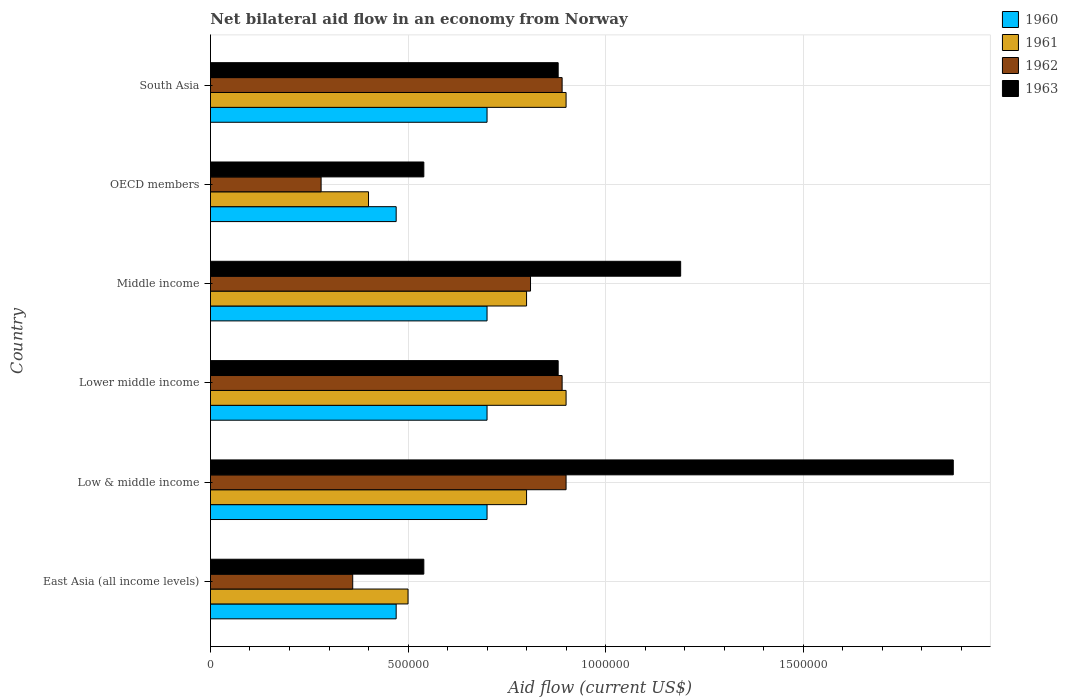How many different coloured bars are there?
Offer a terse response. 4. How many bars are there on the 4th tick from the top?
Your answer should be compact. 4. What is the label of the 5th group of bars from the top?
Your answer should be compact. Low & middle income. What is the net bilateral aid flow in 1960 in Low & middle income?
Your answer should be very brief. 7.00e+05. Across all countries, what is the maximum net bilateral aid flow in 1963?
Keep it short and to the point. 1.88e+06. In which country was the net bilateral aid flow in 1961 maximum?
Ensure brevity in your answer.  Lower middle income. In which country was the net bilateral aid flow in 1963 minimum?
Offer a very short reply. East Asia (all income levels). What is the total net bilateral aid flow in 1961 in the graph?
Your answer should be very brief. 4.30e+06. What is the difference between the net bilateral aid flow in 1961 in East Asia (all income levels) and that in OECD members?
Your response must be concise. 1.00e+05. What is the difference between the net bilateral aid flow in 1962 in OECD members and the net bilateral aid flow in 1963 in Lower middle income?
Your answer should be very brief. -6.00e+05. What is the average net bilateral aid flow in 1961 per country?
Keep it short and to the point. 7.17e+05. What is the difference between the net bilateral aid flow in 1960 and net bilateral aid flow in 1961 in Lower middle income?
Your response must be concise. -2.00e+05. What is the ratio of the net bilateral aid flow in 1960 in East Asia (all income levels) to that in Lower middle income?
Give a very brief answer. 0.67. Is the net bilateral aid flow in 1963 in Low & middle income less than that in South Asia?
Keep it short and to the point. No. Is the difference between the net bilateral aid flow in 1960 in Low & middle income and Middle income greater than the difference between the net bilateral aid flow in 1961 in Low & middle income and Middle income?
Your answer should be very brief. No. What is the difference between the highest and the second highest net bilateral aid flow in 1962?
Your response must be concise. 10000. In how many countries, is the net bilateral aid flow in 1963 greater than the average net bilateral aid flow in 1963 taken over all countries?
Your answer should be very brief. 2. Is the sum of the net bilateral aid flow in 1962 in Lower middle income and Middle income greater than the maximum net bilateral aid flow in 1960 across all countries?
Offer a terse response. Yes. Is it the case that in every country, the sum of the net bilateral aid flow in 1963 and net bilateral aid flow in 1962 is greater than the sum of net bilateral aid flow in 1960 and net bilateral aid flow in 1961?
Your response must be concise. No. Is it the case that in every country, the sum of the net bilateral aid flow in 1963 and net bilateral aid flow in 1961 is greater than the net bilateral aid flow in 1960?
Make the answer very short. Yes. How many countries are there in the graph?
Provide a short and direct response. 6. Are the values on the major ticks of X-axis written in scientific E-notation?
Give a very brief answer. No. Where does the legend appear in the graph?
Provide a succinct answer. Top right. How many legend labels are there?
Keep it short and to the point. 4. What is the title of the graph?
Keep it short and to the point. Net bilateral aid flow in an economy from Norway. Does "1985" appear as one of the legend labels in the graph?
Ensure brevity in your answer.  No. What is the Aid flow (current US$) of 1961 in East Asia (all income levels)?
Make the answer very short. 5.00e+05. What is the Aid flow (current US$) in 1963 in East Asia (all income levels)?
Make the answer very short. 5.40e+05. What is the Aid flow (current US$) in 1960 in Low & middle income?
Provide a short and direct response. 7.00e+05. What is the Aid flow (current US$) of 1961 in Low & middle income?
Offer a terse response. 8.00e+05. What is the Aid flow (current US$) of 1963 in Low & middle income?
Provide a succinct answer. 1.88e+06. What is the Aid flow (current US$) in 1960 in Lower middle income?
Keep it short and to the point. 7.00e+05. What is the Aid flow (current US$) in 1962 in Lower middle income?
Your answer should be compact. 8.90e+05. What is the Aid flow (current US$) in 1963 in Lower middle income?
Your response must be concise. 8.80e+05. What is the Aid flow (current US$) in 1960 in Middle income?
Your answer should be very brief. 7.00e+05. What is the Aid flow (current US$) in 1961 in Middle income?
Give a very brief answer. 8.00e+05. What is the Aid flow (current US$) in 1962 in Middle income?
Keep it short and to the point. 8.10e+05. What is the Aid flow (current US$) in 1963 in Middle income?
Ensure brevity in your answer.  1.19e+06. What is the Aid flow (current US$) in 1961 in OECD members?
Your response must be concise. 4.00e+05. What is the Aid flow (current US$) in 1962 in OECD members?
Keep it short and to the point. 2.80e+05. What is the Aid flow (current US$) in 1963 in OECD members?
Your answer should be compact. 5.40e+05. What is the Aid flow (current US$) in 1962 in South Asia?
Your response must be concise. 8.90e+05. What is the Aid flow (current US$) in 1963 in South Asia?
Give a very brief answer. 8.80e+05. Across all countries, what is the maximum Aid flow (current US$) of 1960?
Offer a very short reply. 7.00e+05. Across all countries, what is the maximum Aid flow (current US$) in 1961?
Your answer should be compact. 9.00e+05. Across all countries, what is the maximum Aid flow (current US$) in 1962?
Give a very brief answer. 9.00e+05. Across all countries, what is the maximum Aid flow (current US$) of 1963?
Make the answer very short. 1.88e+06. Across all countries, what is the minimum Aid flow (current US$) of 1960?
Make the answer very short. 4.70e+05. Across all countries, what is the minimum Aid flow (current US$) of 1963?
Offer a terse response. 5.40e+05. What is the total Aid flow (current US$) of 1960 in the graph?
Provide a short and direct response. 3.74e+06. What is the total Aid flow (current US$) in 1961 in the graph?
Provide a short and direct response. 4.30e+06. What is the total Aid flow (current US$) in 1962 in the graph?
Make the answer very short. 4.13e+06. What is the total Aid flow (current US$) in 1963 in the graph?
Your answer should be very brief. 5.91e+06. What is the difference between the Aid flow (current US$) of 1960 in East Asia (all income levels) and that in Low & middle income?
Your answer should be compact. -2.30e+05. What is the difference between the Aid flow (current US$) of 1961 in East Asia (all income levels) and that in Low & middle income?
Your answer should be very brief. -3.00e+05. What is the difference between the Aid flow (current US$) of 1962 in East Asia (all income levels) and that in Low & middle income?
Make the answer very short. -5.40e+05. What is the difference between the Aid flow (current US$) of 1963 in East Asia (all income levels) and that in Low & middle income?
Provide a short and direct response. -1.34e+06. What is the difference between the Aid flow (current US$) in 1960 in East Asia (all income levels) and that in Lower middle income?
Provide a short and direct response. -2.30e+05. What is the difference between the Aid flow (current US$) of 1961 in East Asia (all income levels) and that in Lower middle income?
Your answer should be very brief. -4.00e+05. What is the difference between the Aid flow (current US$) in 1962 in East Asia (all income levels) and that in Lower middle income?
Your answer should be very brief. -5.30e+05. What is the difference between the Aid flow (current US$) in 1963 in East Asia (all income levels) and that in Lower middle income?
Your answer should be compact. -3.40e+05. What is the difference between the Aid flow (current US$) in 1962 in East Asia (all income levels) and that in Middle income?
Your answer should be compact. -4.50e+05. What is the difference between the Aid flow (current US$) in 1963 in East Asia (all income levels) and that in Middle income?
Keep it short and to the point. -6.50e+05. What is the difference between the Aid flow (current US$) of 1962 in East Asia (all income levels) and that in OECD members?
Your answer should be compact. 8.00e+04. What is the difference between the Aid flow (current US$) in 1960 in East Asia (all income levels) and that in South Asia?
Keep it short and to the point. -2.30e+05. What is the difference between the Aid flow (current US$) of 1961 in East Asia (all income levels) and that in South Asia?
Make the answer very short. -4.00e+05. What is the difference between the Aid flow (current US$) of 1962 in East Asia (all income levels) and that in South Asia?
Your response must be concise. -5.30e+05. What is the difference between the Aid flow (current US$) of 1960 in Low & middle income and that in Lower middle income?
Keep it short and to the point. 0. What is the difference between the Aid flow (current US$) in 1962 in Low & middle income and that in Lower middle income?
Ensure brevity in your answer.  10000. What is the difference between the Aid flow (current US$) in 1962 in Low & middle income and that in Middle income?
Your answer should be compact. 9.00e+04. What is the difference between the Aid flow (current US$) of 1963 in Low & middle income and that in Middle income?
Ensure brevity in your answer.  6.90e+05. What is the difference between the Aid flow (current US$) in 1962 in Low & middle income and that in OECD members?
Your answer should be compact. 6.20e+05. What is the difference between the Aid flow (current US$) of 1963 in Low & middle income and that in OECD members?
Ensure brevity in your answer.  1.34e+06. What is the difference between the Aid flow (current US$) in 1960 in Low & middle income and that in South Asia?
Offer a very short reply. 0. What is the difference between the Aid flow (current US$) of 1961 in Low & middle income and that in South Asia?
Your answer should be compact. -1.00e+05. What is the difference between the Aid flow (current US$) of 1962 in Low & middle income and that in South Asia?
Provide a succinct answer. 10000. What is the difference between the Aid flow (current US$) of 1960 in Lower middle income and that in Middle income?
Provide a succinct answer. 0. What is the difference between the Aid flow (current US$) of 1963 in Lower middle income and that in Middle income?
Your response must be concise. -3.10e+05. What is the difference between the Aid flow (current US$) in 1960 in Lower middle income and that in OECD members?
Provide a succinct answer. 2.30e+05. What is the difference between the Aid flow (current US$) of 1962 in Lower middle income and that in OECD members?
Keep it short and to the point. 6.10e+05. What is the difference between the Aid flow (current US$) in 1963 in Lower middle income and that in OECD members?
Give a very brief answer. 3.40e+05. What is the difference between the Aid flow (current US$) of 1960 in Lower middle income and that in South Asia?
Your answer should be very brief. 0. What is the difference between the Aid flow (current US$) of 1961 in Lower middle income and that in South Asia?
Your answer should be very brief. 0. What is the difference between the Aid flow (current US$) of 1962 in Lower middle income and that in South Asia?
Give a very brief answer. 0. What is the difference between the Aid flow (current US$) of 1963 in Lower middle income and that in South Asia?
Your response must be concise. 0. What is the difference between the Aid flow (current US$) in 1962 in Middle income and that in OECD members?
Your answer should be very brief. 5.30e+05. What is the difference between the Aid flow (current US$) of 1963 in Middle income and that in OECD members?
Your response must be concise. 6.50e+05. What is the difference between the Aid flow (current US$) of 1960 in Middle income and that in South Asia?
Your response must be concise. 0. What is the difference between the Aid flow (current US$) in 1961 in Middle income and that in South Asia?
Ensure brevity in your answer.  -1.00e+05. What is the difference between the Aid flow (current US$) of 1962 in Middle income and that in South Asia?
Offer a very short reply. -8.00e+04. What is the difference between the Aid flow (current US$) of 1963 in Middle income and that in South Asia?
Make the answer very short. 3.10e+05. What is the difference between the Aid flow (current US$) of 1960 in OECD members and that in South Asia?
Keep it short and to the point. -2.30e+05. What is the difference between the Aid flow (current US$) in 1961 in OECD members and that in South Asia?
Keep it short and to the point. -5.00e+05. What is the difference between the Aid flow (current US$) of 1962 in OECD members and that in South Asia?
Keep it short and to the point. -6.10e+05. What is the difference between the Aid flow (current US$) in 1960 in East Asia (all income levels) and the Aid flow (current US$) in 1961 in Low & middle income?
Your answer should be compact. -3.30e+05. What is the difference between the Aid flow (current US$) in 1960 in East Asia (all income levels) and the Aid flow (current US$) in 1962 in Low & middle income?
Provide a short and direct response. -4.30e+05. What is the difference between the Aid flow (current US$) in 1960 in East Asia (all income levels) and the Aid flow (current US$) in 1963 in Low & middle income?
Offer a very short reply. -1.41e+06. What is the difference between the Aid flow (current US$) in 1961 in East Asia (all income levels) and the Aid flow (current US$) in 1962 in Low & middle income?
Ensure brevity in your answer.  -4.00e+05. What is the difference between the Aid flow (current US$) in 1961 in East Asia (all income levels) and the Aid flow (current US$) in 1963 in Low & middle income?
Ensure brevity in your answer.  -1.38e+06. What is the difference between the Aid flow (current US$) in 1962 in East Asia (all income levels) and the Aid flow (current US$) in 1963 in Low & middle income?
Offer a terse response. -1.52e+06. What is the difference between the Aid flow (current US$) in 1960 in East Asia (all income levels) and the Aid flow (current US$) in 1961 in Lower middle income?
Your response must be concise. -4.30e+05. What is the difference between the Aid flow (current US$) in 1960 in East Asia (all income levels) and the Aid flow (current US$) in 1962 in Lower middle income?
Provide a short and direct response. -4.20e+05. What is the difference between the Aid flow (current US$) in 1960 in East Asia (all income levels) and the Aid flow (current US$) in 1963 in Lower middle income?
Ensure brevity in your answer.  -4.10e+05. What is the difference between the Aid flow (current US$) of 1961 in East Asia (all income levels) and the Aid flow (current US$) of 1962 in Lower middle income?
Your response must be concise. -3.90e+05. What is the difference between the Aid flow (current US$) in 1961 in East Asia (all income levels) and the Aid flow (current US$) in 1963 in Lower middle income?
Ensure brevity in your answer.  -3.80e+05. What is the difference between the Aid flow (current US$) of 1962 in East Asia (all income levels) and the Aid flow (current US$) of 1963 in Lower middle income?
Provide a short and direct response. -5.20e+05. What is the difference between the Aid flow (current US$) of 1960 in East Asia (all income levels) and the Aid flow (current US$) of 1961 in Middle income?
Keep it short and to the point. -3.30e+05. What is the difference between the Aid flow (current US$) in 1960 in East Asia (all income levels) and the Aid flow (current US$) in 1962 in Middle income?
Ensure brevity in your answer.  -3.40e+05. What is the difference between the Aid flow (current US$) of 1960 in East Asia (all income levels) and the Aid flow (current US$) of 1963 in Middle income?
Provide a succinct answer. -7.20e+05. What is the difference between the Aid flow (current US$) in 1961 in East Asia (all income levels) and the Aid flow (current US$) in 1962 in Middle income?
Provide a short and direct response. -3.10e+05. What is the difference between the Aid flow (current US$) in 1961 in East Asia (all income levels) and the Aid flow (current US$) in 1963 in Middle income?
Give a very brief answer. -6.90e+05. What is the difference between the Aid flow (current US$) in 1962 in East Asia (all income levels) and the Aid flow (current US$) in 1963 in Middle income?
Give a very brief answer. -8.30e+05. What is the difference between the Aid flow (current US$) in 1960 in East Asia (all income levels) and the Aid flow (current US$) in 1962 in OECD members?
Your answer should be compact. 1.90e+05. What is the difference between the Aid flow (current US$) of 1961 in East Asia (all income levels) and the Aid flow (current US$) of 1962 in OECD members?
Your answer should be compact. 2.20e+05. What is the difference between the Aid flow (current US$) of 1961 in East Asia (all income levels) and the Aid flow (current US$) of 1963 in OECD members?
Keep it short and to the point. -4.00e+04. What is the difference between the Aid flow (current US$) in 1960 in East Asia (all income levels) and the Aid flow (current US$) in 1961 in South Asia?
Provide a succinct answer. -4.30e+05. What is the difference between the Aid flow (current US$) of 1960 in East Asia (all income levels) and the Aid flow (current US$) of 1962 in South Asia?
Give a very brief answer. -4.20e+05. What is the difference between the Aid flow (current US$) in 1960 in East Asia (all income levels) and the Aid flow (current US$) in 1963 in South Asia?
Your answer should be compact. -4.10e+05. What is the difference between the Aid flow (current US$) in 1961 in East Asia (all income levels) and the Aid flow (current US$) in 1962 in South Asia?
Provide a succinct answer. -3.90e+05. What is the difference between the Aid flow (current US$) of 1961 in East Asia (all income levels) and the Aid flow (current US$) of 1963 in South Asia?
Your response must be concise. -3.80e+05. What is the difference between the Aid flow (current US$) in 1962 in East Asia (all income levels) and the Aid flow (current US$) in 1963 in South Asia?
Provide a short and direct response. -5.20e+05. What is the difference between the Aid flow (current US$) of 1960 in Low & middle income and the Aid flow (current US$) of 1961 in Lower middle income?
Your answer should be compact. -2.00e+05. What is the difference between the Aid flow (current US$) in 1960 in Low & middle income and the Aid flow (current US$) in 1963 in Lower middle income?
Provide a short and direct response. -1.80e+05. What is the difference between the Aid flow (current US$) in 1961 in Low & middle income and the Aid flow (current US$) in 1962 in Lower middle income?
Provide a succinct answer. -9.00e+04. What is the difference between the Aid flow (current US$) in 1962 in Low & middle income and the Aid flow (current US$) in 1963 in Lower middle income?
Make the answer very short. 2.00e+04. What is the difference between the Aid flow (current US$) in 1960 in Low & middle income and the Aid flow (current US$) in 1963 in Middle income?
Your answer should be compact. -4.90e+05. What is the difference between the Aid flow (current US$) in 1961 in Low & middle income and the Aid flow (current US$) in 1963 in Middle income?
Ensure brevity in your answer.  -3.90e+05. What is the difference between the Aid flow (current US$) in 1962 in Low & middle income and the Aid flow (current US$) in 1963 in Middle income?
Offer a terse response. -2.90e+05. What is the difference between the Aid flow (current US$) in 1960 in Low & middle income and the Aid flow (current US$) in 1961 in OECD members?
Offer a terse response. 3.00e+05. What is the difference between the Aid flow (current US$) of 1961 in Low & middle income and the Aid flow (current US$) of 1962 in OECD members?
Keep it short and to the point. 5.20e+05. What is the difference between the Aid flow (current US$) in 1961 in Low & middle income and the Aid flow (current US$) in 1963 in OECD members?
Provide a succinct answer. 2.60e+05. What is the difference between the Aid flow (current US$) in 1960 in Low & middle income and the Aid flow (current US$) in 1961 in South Asia?
Your answer should be compact. -2.00e+05. What is the difference between the Aid flow (current US$) of 1960 in Low & middle income and the Aid flow (current US$) of 1962 in South Asia?
Provide a short and direct response. -1.90e+05. What is the difference between the Aid flow (current US$) in 1960 in Low & middle income and the Aid flow (current US$) in 1963 in South Asia?
Your answer should be very brief. -1.80e+05. What is the difference between the Aid flow (current US$) in 1961 in Low & middle income and the Aid flow (current US$) in 1963 in South Asia?
Ensure brevity in your answer.  -8.00e+04. What is the difference between the Aid flow (current US$) of 1960 in Lower middle income and the Aid flow (current US$) of 1962 in Middle income?
Your response must be concise. -1.10e+05. What is the difference between the Aid flow (current US$) in 1960 in Lower middle income and the Aid flow (current US$) in 1963 in Middle income?
Provide a short and direct response. -4.90e+05. What is the difference between the Aid flow (current US$) of 1961 in Lower middle income and the Aid flow (current US$) of 1963 in Middle income?
Your answer should be very brief. -2.90e+05. What is the difference between the Aid flow (current US$) of 1960 in Lower middle income and the Aid flow (current US$) of 1961 in OECD members?
Give a very brief answer. 3.00e+05. What is the difference between the Aid flow (current US$) in 1960 in Lower middle income and the Aid flow (current US$) in 1963 in OECD members?
Your answer should be very brief. 1.60e+05. What is the difference between the Aid flow (current US$) in 1961 in Lower middle income and the Aid flow (current US$) in 1962 in OECD members?
Provide a short and direct response. 6.20e+05. What is the difference between the Aid flow (current US$) in 1962 in Lower middle income and the Aid flow (current US$) in 1963 in OECD members?
Offer a very short reply. 3.50e+05. What is the difference between the Aid flow (current US$) in 1960 in Lower middle income and the Aid flow (current US$) in 1961 in South Asia?
Provide a succinct answer. -2.00e+05. What is the difference between the Aid flow (current US$) in 1960 in Lower middle income and the Aid flow (current US$) in 1963 in South Asia?
Provide a short and direct response. -1.80e+05. What is the difference between the Aid flow (current US$) of 1961 in Lower middle income and the Aid flow (current US$) of 1963 in South Asia?
Ensure brevity in your answer.  2.00e+04. What is the difference between the Aid flow (current US$) of 1962 in Lower middle income and the Aid flow (current US$) of 1963 in South Asia?
Your response must be concise. 10000. What is the difference between the Aid flow (current US$) of 1960 in Middle income and the Aid flow (current US$) of 1961 in OECD members?
Ensure brevity in your answer.  3.00e+05. What is the difference between the Aid flow (current US$) of 1960 in Middle income and the Aid flow (current US$) of 1963 in OECD members?
Ensure brevity in your answer.  1.60e+05. What is the difference between the Aid flow (current US$) of 1961 in Middle income and the Aid flow (current US$) of 1962 in OECD members?
Ensure brevity in your answer.  5.20e+05. What is the difference between the Aid flow (current US$) of 1962 in Middle income and the Aid flow (current US$) of 1963 in OECD members?
Make the answer very short. 2.70e+05. What is the difference between the Aid flow (current US$) in 1960 in Middle income and the Aid flow (current US$) in 1961 in South Asia?
Provide a succinct answer. -2.00e+05. What is the difference between the Aid flow (current US$) in 1960 in Middle income and the Aid flow (current US$) in 1962 in South Asia?
Your answer should be compact. -1.90e+05. What is the difference between the Aid flow (current US$) of 1961 in Middle income and the Aid flow (current US$) of 1962 in South Asia?
Offer a very short reply. -9.00e+04. What is the difference between the Aid flow (current US$) of 1960 in OECD members and the Aid flow (current US$) of 1961 in South Asia?
Keep it short and to the point. -4.30e+05. What is the difference between the Aid flow (current US$) in 1960 in OECD members and the Aid flow (current US$) in 1962 in South Asia?
Ensure brevity in your answer.  -4.20e+05. What is the difference between the Aid flow (current US$) of 1960 in OECD members and the Aid flow (current US$) of 1963 in South Asia?
Offer a terse response. -4.10e+05. What is the difference between the Aid flow (current US$) in 1961 in OECD members and the Aid flow (current US$) in 1962 in South Asia?
Offer a terse response. -4.90e+05. What is the difference between the Aid flow (current US$) of 1961 in OECD members and the Aid flow (current US$) of 1963 in South Asia?
Provide a short and direct response. -4.80e+05. What is the difference between the Aid flow (current US$) in 1962 in OECD members and the Aid flow (current US$) in 1963 in South Asia?
Provide a succinct answer. -6.00e+05. What is the average Aid flow (current US$) of 1960 per country?
Make the answer very short. 6.23e+05. What is the average Aid flow (current US$) of 1961 per country?
Give a very brief answer. 7.17e+05. What is the average Aid flow (current US$) in 1962 per country?
Give a very brief answer. 6.88e+05. What is the average Aid flow (current US$) of 1963 per country?
Your answer should be very brief. 9.85e+05. What is the difference between the Aid flow (current US$) in 1960 and Aid flow (current US$) in 1961 in East Asia (all income levels)?
Ensure brevity in your answer.  -3.00e+04. What is the difference between the Aid flow (current US$) in 1960 and Aid flow (current US$) in 1962 in East Asia (all income levels)?
Ensure brevity in your answer.  1.10e+05. What is the difference between the Aid flow (current US$) of 1960 and Aid flow (current US$) of 1963 in East Asia (all income levels)?
Ensure brevity in your answer.  -7.00e+04. What is the difference between the Aid flow (current US$) in 1961 and Aid flow (current US$) in 1962 in East Asia (all income levels)?
Offer a terse response. 1.40e+05. What is the difference between the Aid flow (current US$) of 1960 and Aid flow (current US$) of 1961 in Low & middle income?
Your response must be concise. -1.00e+05. What is the difference between the Aid flow (current US$) in 1960 and Aid flow (current US$) in 1963 in Low & middle income?
Provide a succinct answer. -1.18e+06. What is the difference between the Aid flow (current US$) in 1961 and Aid flow (current US$) in 1962 in Low & middle income?
Ensure brevity in your answer.  -1.00e+05. What is the difference between the Aid flow (current US$) of 1961 and Aid flow (current US$) of 1963 in Low & middle income?
Offer a terse response. -1.08e+06. What is the difference between the Aid flow (current US$) of 1962 and Aid flow (current US$) of 1963 in Low & middle income?
Keep it short and to the point. -9.80e+05. What is the difference between the Aid flow (current US$) of 1960 and Aid flow (current US$) of 1962 in Lower middle income?
Provide a succinct answer. -1.90e+05. What is the difference between the Aid flow (current US$) of 1960 and Aid flow (current US$) of 1963 in Lower middle income?
Give a very brief answer. -1.80e+05. What is the difference between the Aid flow (current US$) of 1961 and Aid flow (current US$) of 1963 in Lower middle income?
Give a very brief answer. 2.00e+04. What is the difference between the Aid flow (current US$) of 1962 and Aid flow (current US$) of 1963 in Lower middle income?
Provide a succinct answer. 10000. What is the difference between the Aid flow (current US$) in 1960 and Aid flow (current US$) in 1963 in Middle income?
Make the answer very short. -4.90e+05. What is the difference between the Aid flow (current US$) in 1961 and Aid flow (current US$) in 1962 in Middle income?
Give a very brief answer. -10000. What is the difference between the Aid flow (current US$) of 1961 and Aid flow (current US$) of 1963 in Middle income?
Keep it short and to the point. -3.90e+05. What is the difference between the Aid flow (current US$) of 1962 and Aid flow (current US$) of 1963 in Middle income?
Offer a terse response. -3.80e+05. What is the difference between the Aid flow (current US$) in 1960 and Aid flow (current US$) in 1961 in OECD members?
Your response must be concise. 7.00e+04. What is the difference between the Aid flow (current US$) in 1961 and Aid flow (current US$) in 1963 in OECD members?
Your answer should be very brief. -1.40e+05. What is the difference between the Aid flow (current US$) of 1962 and Aid flow (current US$) of 1963 in OECD members?
Provide a succinct answer. -2.60e+05. What is the difference between the Aid flow (current US$) of 1960 and Aid flow (current US$) of 1961 in South Asia?
Give a very brief answer. -2.00e+05. What is the difference between the Aid flow (current US$) in 1960 and Aid flow (current US$) in 1963 in South Asia?
Ensure brevity in your answer.  -1.80e+05. What is the difference between the Aid flow (current US$) in 1961 and Aid flow (current US$) in 1962 in South Asia?
Ensure brevity in your answer.  10000. What is the ratio of the Aid flow (current US$) in 1960 in East Asia (all income levels) to that in Low & middle income?
Provide a short and direct response. 0.67. What is the ratio of the Aid flow (current US$) in 1963 in East Asia (all income levels) to that in Low & middle income?
Offer a very short reply. 0.29. What is the ratio of the Aid flow (current US$) of 1960 in East Asia (all income levels) to that in Lower middle income?
Provide a succinct answer. 0.67. What is the ratio of the Aid flow (current US$) in 1961 in East Asia (all income levels) to that in Lower middle income?
Ensure brevity in your answer.  0.56. What is the ratio of the Aid flow (current US$) in 1962 in East Asia (all income levels) to that in Lower middle income?
Keep it short and to the point. 0.4. What is the ratio of the Aid flow (current US$) of 1963 in East Asia (all income levels) to that in Lower middle income?
Offer a terse response. 0.61. What is the ratio of the Aid flow (current US$) of 1960 in East Asia (all income levels) to that in Middle income?
Make the answer very short. 0.67. What is the ratio of the Aid flow (current US$) in 1961 in East Asia (all income levels) to that in Middle income?
Give a very brief answer. 0.62. What is the ratio of the Aid flow (current US$) of 1962 in East Asia (all income levels) to that in Middle income?
Make the answer very short. 0.44. What is the ratio of the Aid flow (current US$) in 1963 in East Asia (all income levels) to that in Middle income?
Offer a terse response. 0.45. What is the ratio of the Aid flow (current US$) in 1960 in East Asia (all income levels) to that in OECD members?
Offer a terse response. 1. What is the ratio of the Aid flow (current US$) of 1962 in East Asia (all income levels) to that in OECD members?
Your answer should be compact. 1.29. What is the ratio of the Aid flow (current US$) of 1960 in East Asia (all income levels) to that in South Asia?
Make the answer very short. 0.67. What is the ratio of the Aid flow (current US$) in 1961 in East Asia (all income levels) to that in South Asia?
Offer a terse response. 0.56. What is the ratio of the Aid flow (current US$) of 1962 in East Asia (all income levels) to that in South Asia?
Make the answer very short. 0.4. What is the ratio of the Aid flow (current US$) in 1963 in East Asia (all income levels) to that in South Asia?
Provide a succinct answer. 0.61. What is the ratio of the Aid flow (current US$) in 1960 in Low & middle income to that in Lower middle income?
Your answer should be very brief. 1. What is the ratio of the Aid flow (current US$) in 1961 in Low & middle income to that in Lower middle income?
Make the answer very short. 0.89. What is the ratio of the Aid flow (current US$) in 1962 in Low & middle income to that in Lower middle income?
Ensure brevity in your answer.  1.01. What is the ratio of the Aid flow (current US$) in 1963 in Low & middle income to that in Lower middle income?
Ensure brevity in your answer.  2.14. What is the ratio of the Aid flow (current US$) of 1960 in Low & middle income to that in Middle income?
Offer a very short reply. 1. What is the ratio of the Aid flow (current US$) of 1963 in Low & middle income to that in Middle income?
Provide a short and direct response. 1.58. What is the ratio of the Aid flow (current US$) in 1960 in Low & middle income to that in OECD members?
Keep it short and to the point. 1.49. What is the ratio of the Aid flow (current US$) in 1962 in Low & middle income to that in OECD members?
Keep it short and to the point. 3.21. What is the ratio of the Aid flow (current US$) of 1963 in Low & middle income to that in OECD members?
Offer a terse response. 3.48. What is the ratio of the Aid flow (current US$) in 1961 in Low & middle income to that in South Asia?
Make the answer very short. 0.89. What is the ratio of the Aid flow (current US$) in 1962 in Low & middle income to that in South Asia?
Provide a short and direct response. 1.01. What is the ratio of the Aid flow (current US$) of 1963 in Low & middle income to that in South Asia?
Your answer should be very brief. 2.14. What is the ratio of the Aid flow (current US$) in 1962 in Lower middle income to that in Middle income?
Your answer should be very brief. 1.1. What is the ratio of the Aid flow (current US$) of 1963 in Lower middle income to that in Middle income?
Make the answer very short. 0.74. What is the ratio of the Aid flow (current US$) of 1960 in Lower middle income to that in OECD members?
Offer a terse response. 1.49. What is the ratio of the Aid flow (current US$) in 1961 in Lower middle income to that in OECD members?
Provide a short and direct response. 2.25. What is the ratio of the Aid flow (current US$) in 1962 in Lower middle income to that in OECD members?
Your answer should be very brief. 3.18. What is the ratio of the Aid flow (current US$) of 1963 in Lower middle income to that in OECD members?
Give a very brief answer. 1.63. What is the ratio of the Aid flow (current US$) in 1960 in Lower middle income to that in South Asia?
Your response must be concise. 1. What is the ratio of the Aid flow (current US$) of 1961 in Lower middle income to that in South Asia?
Provide a succinct answer. 1. What is the ratio of the Aid flow (current US$) of 1963 in Lower middle income to that in South Asia?
Offer a very short reply. 1. What is the ratio of the Aid flow (current US$) of 1960 in Middle income to that in OECD members?
Keep it short and to the point. 1.49. What is the ratio of the Aid flow (current US$) of 1961 in Middle income to that in OECD members?
Offer a very short reply. 2. What is the ratio of the Aid flow (current US$) of 1962 in Middle income to that in OECD members?
Offer a terse response. 2.89. What is the ratio of the Aid flow (current US$) of 1963 in Middle income to that in OECD members?
Ensure brevity in your answer.  2.2. What is the ratio of the Aid flow (current US$) of 1962 in Middle income to that in South Asia?
Offer a very short reply. 0.91. What is the ratio of the Aid flow (current US$) of 1963 in Middle income to that in South Asia?
Provide a short and direct response. 1.35. What is the ratio of the Aid flow (current US$) in 1960 in OECD members to that in South Asia?
Keep it short and to the point. 0.67. What is the ratio of the Aid flow (current US$) in 1961 in OECD members to that in South Asia?
Make the answer very short. 0.44. What is the ratio of the Aid flow (current US$) of 1962 in OECD members to that in South Asia?
Give a very brief answer. 0.31. What is the ratio of the Aid flow (current US$) in 1963 in OECD members to that in South Asia?
Give a very brief answer. 0.61. What is the difference between the highest and the second highest Aid flow (current US$) of 1961?
Your answer should be compact. 0. What is the difference between the highest and the second highest Aid flow (current US$) in 1962?
Offer a very short reply. 10000. What is the difference between the highest and the second highest Aid flow (current US$) in 1963?
Make the answer very short. 6.90e+05. What is the difference between the highest and the lowest Aid flow (current US$) in 1961?
Keep it short and to the point. 5.00e+05. What is the difference between the highest and the lowest Aid flow (current US$) of 1962?
Provide a short and direct response. 6.20e+05. What is the difference between the highest and the lowest Aid flow (current US$) of 1963?
Provide a short and direct response. 1.34e+06. 